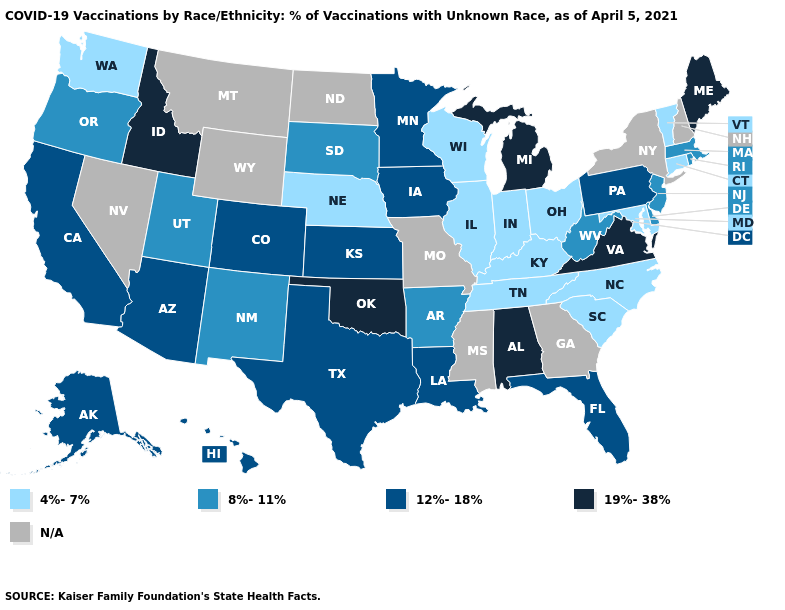Which states have the lowest value in the USA?
Short answer required. Connecticut, Illinois, Indiana, Kentucky, Maryland, Nebraska, North Carolina, Ohio, South Carolina, Tennessee, Vermont, Washington, Wisconsin. Name the states that have a value in the range 19%-38%?
Be succinct. Alabama, Idaho, Maine, Michigan, Oklahoma, Virginia. Among the states that border Alabama , does Florida have the lowest value?
Keep it brief. No. What is the lowest value in the Northeast?
Keep it brief. 4%-7%. What is the value of Massachusetts?
Write a very short answer. 8%-11%. Name the states that have a value in the range N/A?
Answer briefly. Georgia, Mississippi, Missouri, Montana, Nevada, New Hampshire, New York, North Dakota, Wyoming. Name the states that have a value in the range 12%-18%?
Keep it brief. Alaska, Arizona, California, Colorado, Florida, Hawaii, Iowa, Kansas, Louisiana, Minnesota, Pennsylvania, Texas. What is the value of South Carolina?
Keep it brief. 4%-7%. Among the states that border North Dakota , which have the highest value?
Short answer required. Minnesota. What is the value of Texas?
Quick response, please. 12%-18%. Does Arkansas have the highest value in the USA?
Concise answer only. No. Among the states that border Pennsylvania , does Maryland have the highest value?
Keep it brief. No. Does Florida have the highest value in the South?
Keep it brief. No. Does Washington have the lowest value in the West?
Keep it brief. Yes. 